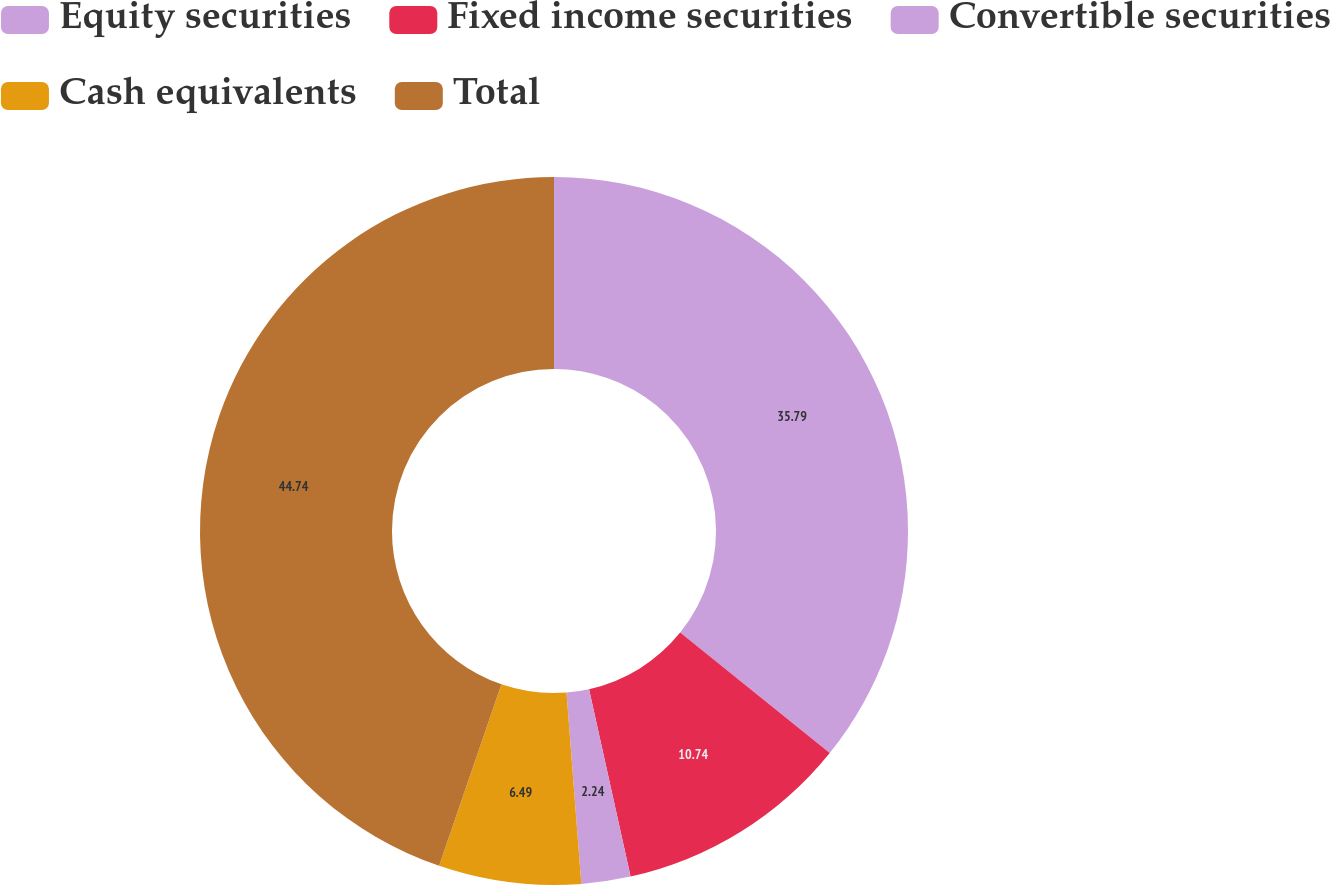<chart> <loc_0><loc_0><loc_500><loc_500><pie_chart><fcel>Equity securities<fcel>Fixed income securities<fcel>Convertible securities<fcel>Cash equivalents<fcel>Total<nl><fcel>35.79%<fcel>10.74%<fcel>2.24%<fcel>6.49%<fcel>44.74%<nl></chart> 